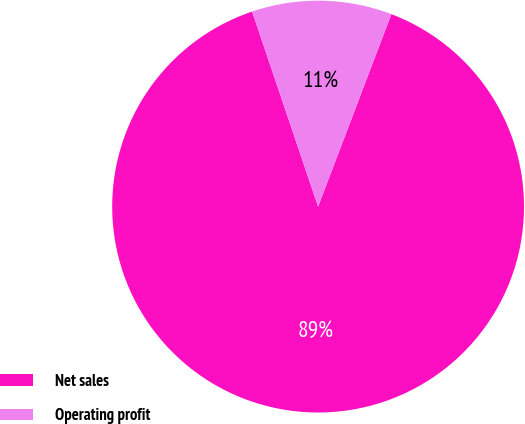<chart> <loc_0><loc_0><loc_500><loc_500><pie_chart><fcel>Net sales<fcel>Operating profit<nl><fcel>89.02%<fcel>10.98%<nl></chart> 